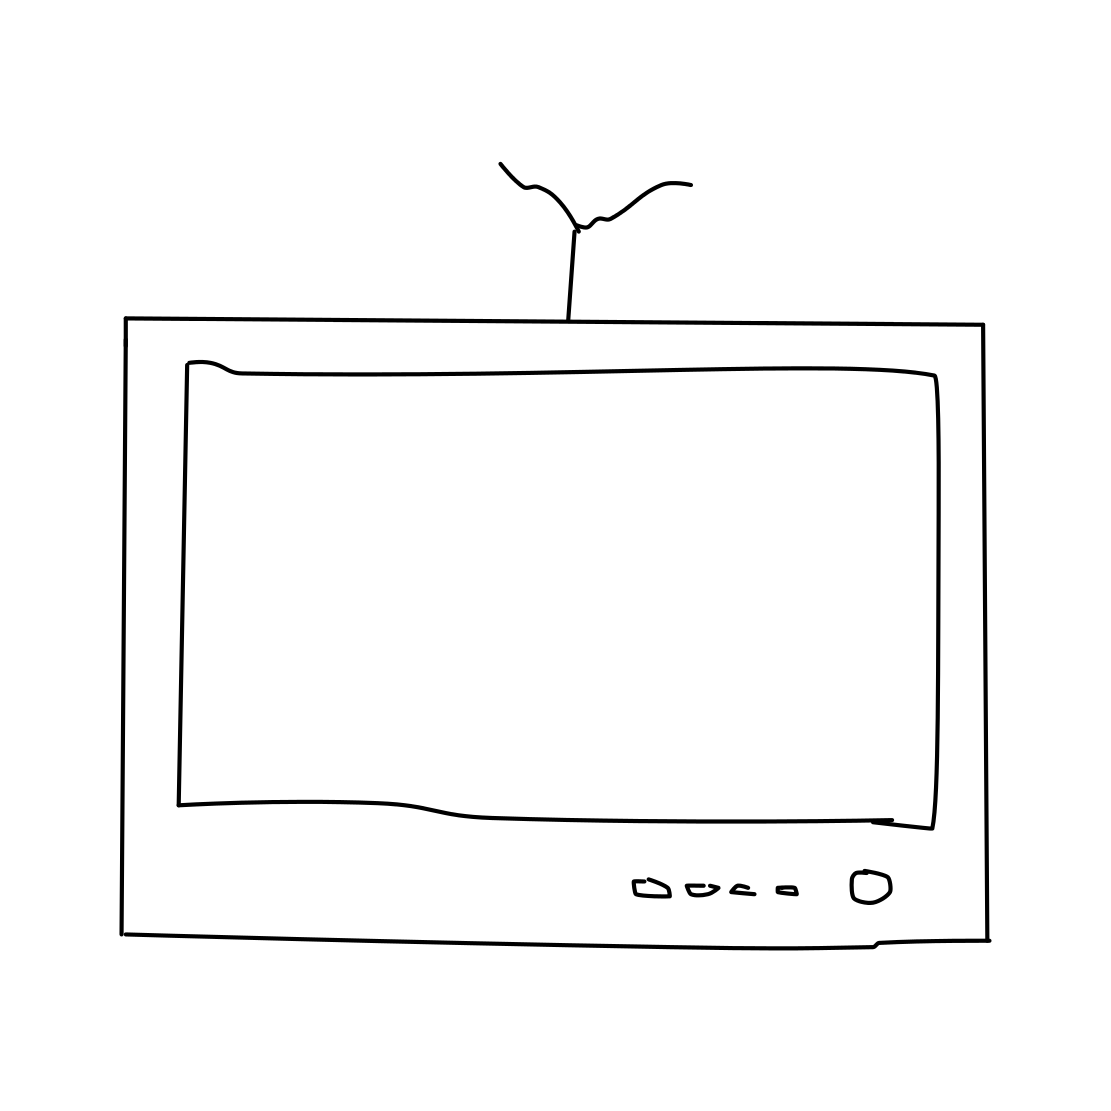How could this image be relevant in today's digital age? This image of an old-style TV could serve various contemporary purposes. It might be used to evoke nostalgia or to illustrate the contrast between past and present technology. It could be part of an educational material explaining the evolution of televisions, or it might be utilized in an artistic way to make a comment on the changing landscape of media consumption. 